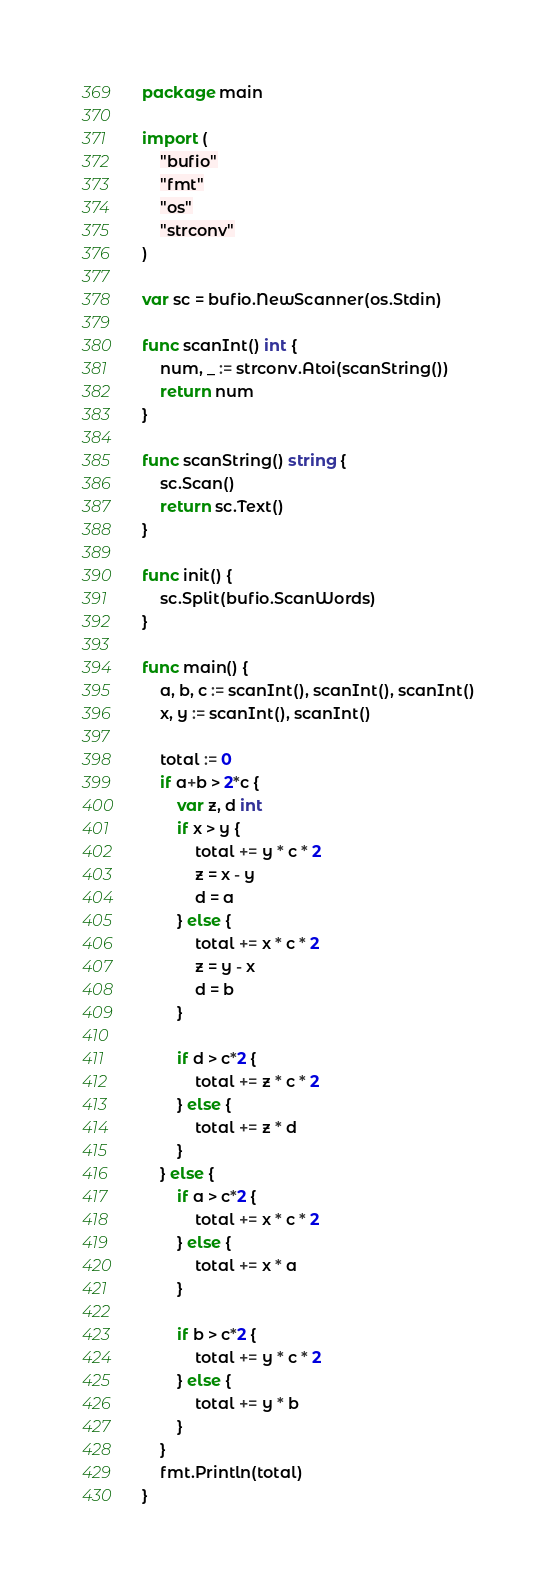Convert code to text. <code><loc_0><loc_0><loc_500><loc_500><_Go_>package main

import (
	"bufio"
	"fmt"
	"os"
	"strconv"
)

var sc = bufio.NewScanner(os.Stdin)

func scanInt() int {
	num, _ := strconv.Atoi(scanString())
	return num
}

func scanString() string {
	sc.Scan()
	return sc.Text()
}

func init() {
	sc.Split(bufio.ScanWords)
}

func main() {
	a, b, c := scanInt(), scanInt(), scanInt()
	x, y := scanInt(), scanInt()

	total := 0
	if a+b > 2*c {
		var z, d int
		if x > y {
			total += y * c * 2
			z = x - y
			d = a
		} else {
			total += x * c * 2
			z = y - x
			d = b
		}

		if d > c*2 {
			total += z * c * 2
		} else {
			total += z * d
		}
	} else {
		if a > c*2 {
			total += x * c * 2
		} else {
			total += x * a
		}

		if b > c*2 {
			total += y * c * 2
		} else {
			total += y * b
		}
	}
	fmt.Println(total)
}
</code> 